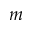Convert formula to latex. <formula><loc_0><loc_0><loc_500><loc_500>m</formula> 